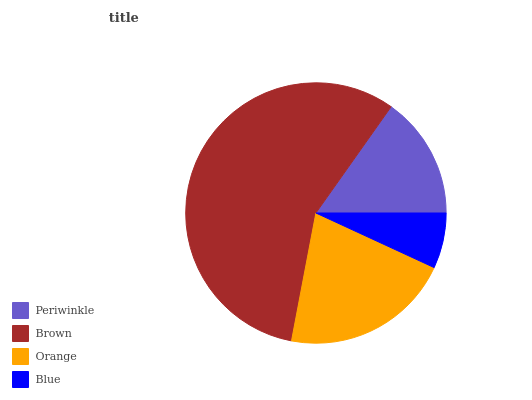Is Blue the minimum?
Answer yes or no. Yes. Is Brown the maximum?
Answer yes or no. Yes. Is Orange the minimum?
Answer yes or no. No. Is Orange the maximum?
Answer yes or no. No. Is Brown greater than Orange?
Answer yes or no. Yes. Is Orange less than Brown?
Answer yes or no. Yes. Is Orange greater than Brown?
Answer yes or no. No. Is Brown less than Orange?
Answer yes or no. No. Is Orange the high median?
Answer yes or no. Yes. Is Periwinkle the low median?
Answer yes or no. Yes. Is Blue the high median?
Answer yes or no. No. Is Orange the low median?
Answer yes or no. No. 